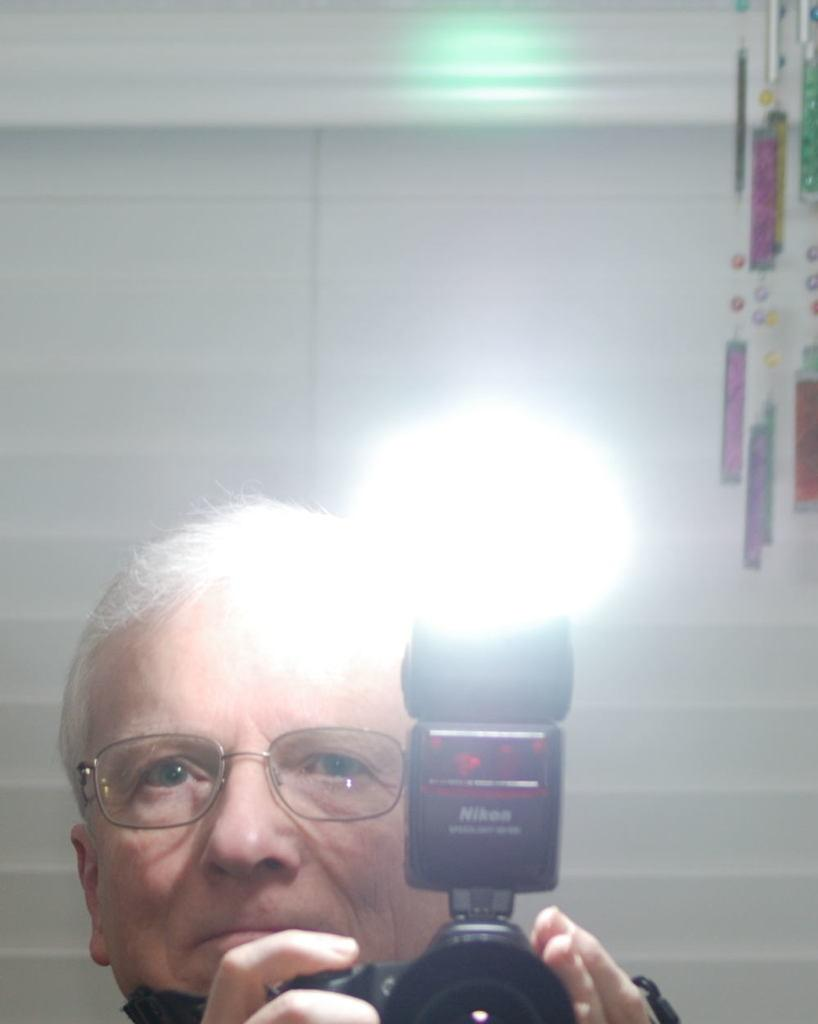Who is present in the image? There is a man in the picture. What is the man wearing? The man is wearing spectacles. What is the man holding in the image? The man is holding a camera. What can be seen in the background of the picture? There is a wall visible in the background of the picture. What objects are located in the top right corner of the image? There are ropes in the top right corner of the image. What type of business is the monkey running in the image? There is no monkey present in the image, and therefore no business can be observed. 